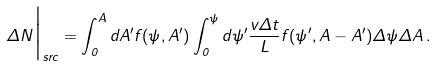<formula> <loc_0><loc_0><loc_500><loc_500>\Delta N \Big { | } _ { s r c } = \int _ { 0 } ^ { A } d A ^ { \prime } f ( \psi , A ^ { \prime } ) \int _ { 0 } ^ { \psi } d \psi ^ { \prime } \frac { v \Delta t } { L } f ( \psi ^ { \prime } , A - A ^ { \prime } ) \Delta \psi \Delta A \, .</formula> 